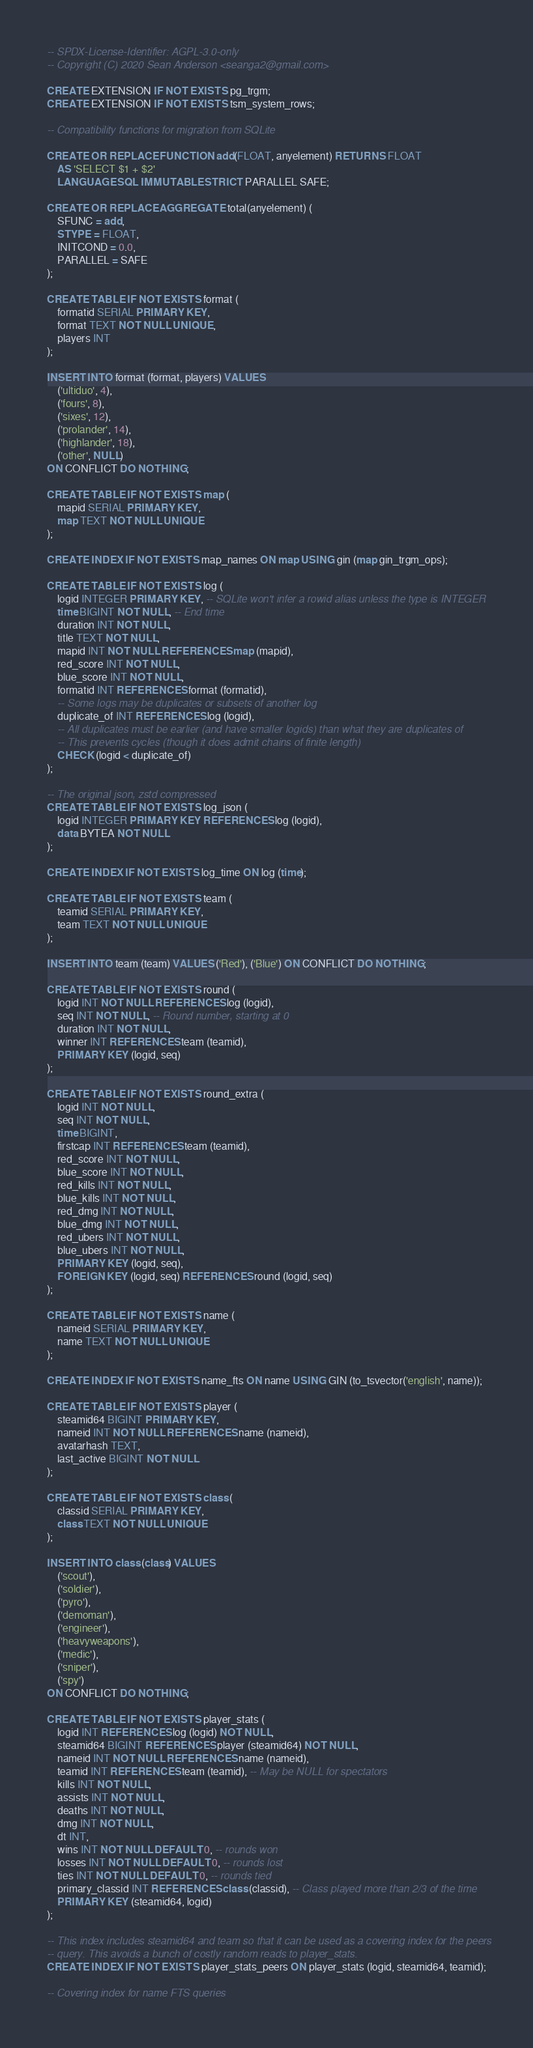Convert code to text. <code><loc_0><loc_0><loc_500><loc_500><_SQL_>-- SPDX-License-Identifier: AGPL-3.0-only
-- Copyright (C) 2020 Sean Anderson <seanga2@gmail.com>

CREATE EXTENSION IF NOT EXISTS pg_trgm;
CREATE EXTENSION IF NOT EXISTS tsm_system_rows;

-- Compatibility functions for migration from SQLite

CREATE OR REPLACE FUNCTION add(FLOAT, anyelement) RETURNS FLOAT
	AS 'SELECT $1 + $2'
	LANGUAGE SQL IMMUTABLE STRICT PARALLEL SAFE;

CREATE OR REPLACE AGGREGATE total(anyelement) (
	SFUNC = add,
	STYPE = FLOAT,
	INITCOND = 0.0,
	PARALLEL = SAFE
);

CREATE TABLE IF NOT EXISTS format (
	formatid SERIAL PRIMARY KEY,
	format TEXT NOT NULL UNIQUE,
	players INT
);

INSERT INTO format (format, players) VALUES
	('ultiduo', 4),
	('fours', 8),
	('sixes', 12),
	('prolander', 14),
	('highlander', 18),
	('other', NULL)
ON CONFLICT DO NOTHING;

CREATE TABLE IF NOT EXISTS map (
	mapid SERIAL PRIMARY KEY,
	map TEXT NOT NULL UNIQUE
);

CREATE INDEX IF NOT EXISTS map_names ON map USING gin (map gin_trgm_ops);

CREATE TABLE IF NOT EXISTS log (
	logid INTEGER PRIMARY KEY, -- SQLite won't infer a rowid alias unless the type is INTEGER
	time BIGINT NOT NULL, -- End time
	duration INT NOT NULL,
	title TEXT NOT NULL,
	mapid INT NOT NULL REFERENCES map (mapid),
	red_score INT NOT NULL,
	blue_score INT NOT NULL,
	formatid INT REFERENCES format (formatid),
	-- Some logs may be duplicates or subsets of another log
	duplicate_of INT REFERENCES log (logid),
	-- All duplicates must be earlier (and have smaller logids) than what they are duplicates of
	-- This prevents cycles (though it does admit chains of finite length)
	CHECK (logid < duplicate_of)
);

-- The original json, zstd compressed
CREATE TABLE IF NOT EXISTS log_json (
	logid INTEGER PRIMARY KEY REFERENCES log (logid),
	data BYTEA NOT NULL
);

CREATE INDEX IF NOT EXISTS log_time ON log (time);

CREATE TABLE IF NOT EXISTS team (
	teamid SERIAL PRIMARY KEY,
	team TEXT NOT NULL UNIQUE
);

INSERT INTO team (team) VALUES ('Red'), ('Blue') ON CONFLICT DO NOTHING;

CREATE TABLE IF NOT EXISTS round (
	logid INT NOT NULL REFERENCES log (logid),
	seq INT NOT NULL, -- Round number, starting at 0
	duration INT NOT NULL,
	winner INT REFERENCES team (teamid),
	PRIMARY KEY (logid, seq)
);

CREATE TABLE IF NOT EXISTS round_extra (
	logid INT NOT NULL,
	seq INT NOT NULL,
	time BIGINT,
	firstcap INT REFERENCES team (teamid),
	red_score INT NOT NULL,
	blue_score INT NOT NULL,
	red_kills INT NOT NULL,
	blue_kills INT NOT NULL,
	red_dmg INT NOT NULL,
	blue_dmg INT NOT NULL,
	red_ubers INT NOT NULL,
	blue_ubers INT NOT NULL,
	PRIMARY KEY (logid, seq),
	FOREIGN KEY (logid, seq) REFERENCES round (logid, seq)
);

CREATE TABLE IF NOT EXISTS name (
	nameid SERIAL PRIMARY KEY,
	name TEXT NOT NULL UNIQUE
);

CREATE INDEX IF NOT EXISTS name_fts ON name USING GIN (to_tsvector('english', name));

CREATE TABLE IF NOT EXISTS player (
	steamid64 BIGINT PRIMARY KEY,
	nameid INT NOT NULL REFERENCES name (nameid),
	avatarhash TEXT,
	last_active BIGINT NOT NULL
);

CREATE TABLE IF NOT EXISTS class (
	classid SERIAL PRIMARY KEY,
	class TEXT NOT NULL UNIQUE
);

INSERT INTO class (class) VALUES
	('scout'),
	('soldier'),
	('pyro'),
	('demoman'),
	('engineer'),
	('heavyweapons'),
	('medic'),
	('sniper'),
	('spy')
ON CONFLICT DO NOTHING;

CREATE TABLE IF NOT EXISTS player_stats (
	logid INT REFERENCES log (logid) NOT NULL,
	steamid64 BIGINT REFERENCES player (steamid64) NOT NULL,
	nameid INT NOT NULL REFERENCES name (nameid),
	teamid INT REFERENCES team (teamid), -- May be NULL for spectators
	kills INT NOT NULL,
	assists INT NOT NULL,
	deaths INT NOT NULL,
	dmg INT NOT NULL,
	dt INT,
	wins INT NOT NULL DEFAULT 0, -- rounds won
	losses INT NOT NULL DEFAULT 0, -- rounds lost
	ties INT NOT NULL DEFAULT 0, -- rounds tied
	primary_classid INT REFERENCES class (classid), -- Class played more than 2/3 of the time
	PRIMARY KEY (steamid64, logid)
);

-- This index includes steamid64 and team so that it can be used as a covering index for the peers
-- query. This avoids a bunch of costly random reads to player_stats.
CREATE INDEX IF NOT EXISTS player_stats_peers ON player_stats (logid, steamid64, teamid);

-- Covering index for name FTS queries</code> 